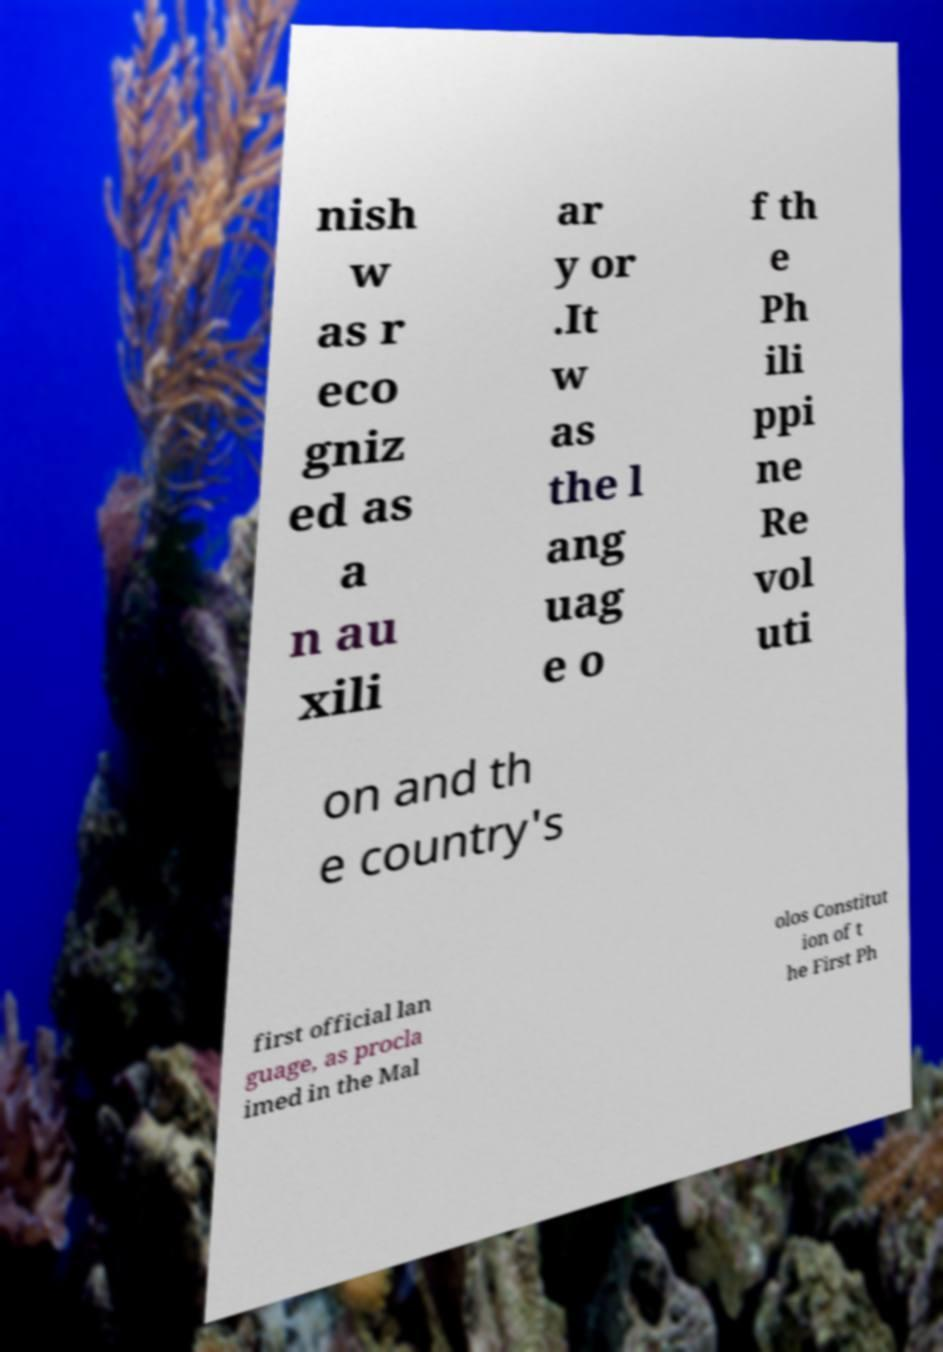What messages or text are displayed in this image? I need them in a readable, typed format. nish w as r eco gniz ed as a n au xili ar y or .It w as the l ang uag e o f th e Ph ili ppi ne Re vol uti on and th e country's first official lan guage, as procla imed in the Mal olos Constitut ion of t he First Ph 